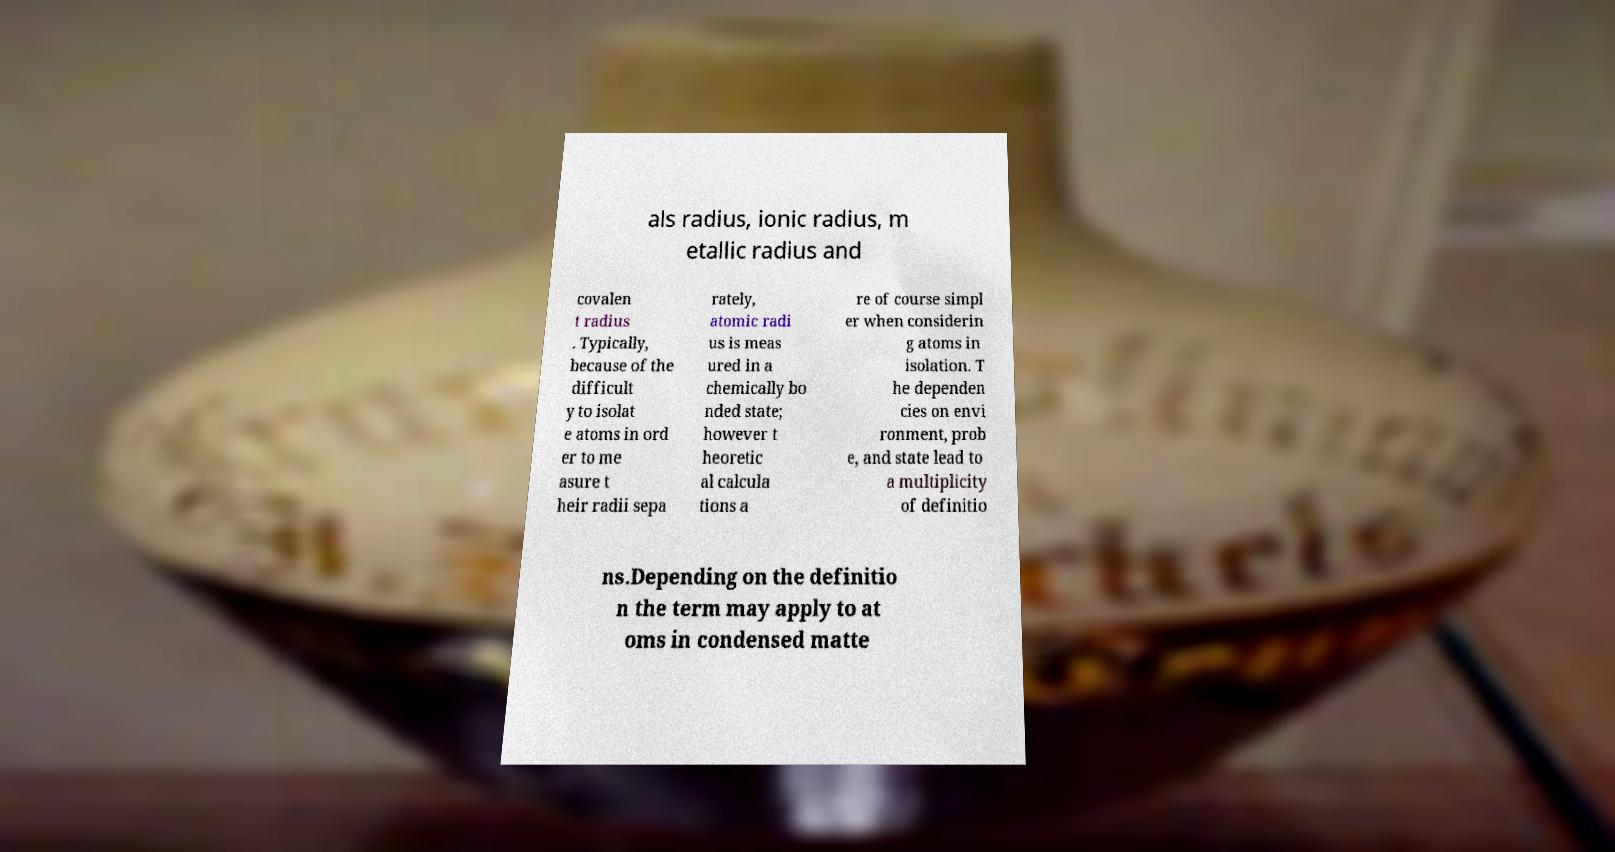I need the written content from this picture converted into text. Can you do that? als radius, ionic radius, m etallic radius and covalen t radius . Typically, because of the difficult y to isolat e atoms in ord er to me asure t heir radii sepa rately, atomic radi us is meas ured in a chemically bo nded state; however t heoretic al calcula tions a re of course simpl er when considerin g atoms in isolation. T he dependen cies on envi ronment, prob e, and state lead to a multiplicity of definitio ns.Depending on the definitio n the term may apply to at oms in condensed matte 